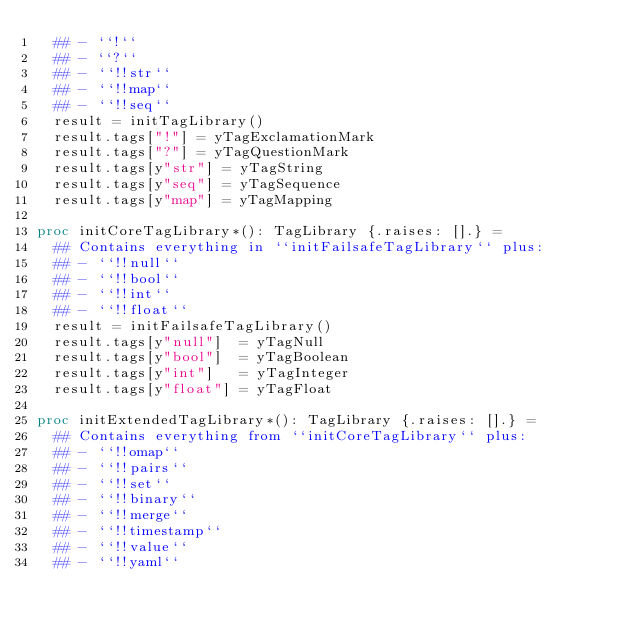Convert code to text. <code><loc_0><loc_0><loc_500><loc_500><_Nim_>  ## - ``!``
  ## - ``?``
  ## - ``!!str``
  ## - ``!!map``
  ## - ``!!seq``
  result = initTagLibrary()
  result.tags["!"] = yTagExclamationMark
  result.tags["?"] = yTagQuestionMark
  result.tags[y"str"] = yTagString
  result.tags[y"seq"] = yTagSequence
  result.tags[y"map"] = yTagMapping

proc initCoreTagLibrary*(): TagLibrary {.raises: [].} =
  ## Contains everything in ``initFailsafeTagLibrary`` plus:
  ## - ``!!null``
  ## - ``!!bool``
  ## - ``!!int``
  ## - ``!!float``
  result = initFailsafeTagLibrary()
  result.tags[y"null"]  = yTagNull
  result.tags[y"bool"]  = yTagBoolean
  result.tags[y"int"]   = yTagInteger
  result.tags[y"float"] = yTagFloat

proc initExtendedTagLibrary*(): TagLibrary {.raises: [].} =
  ## Contains everything from ``initCoreTagLibrary`` plus:
  ## - ``!!omap``
  ## - ``!!pairs``
  ## - ``!!set``
  ## - ``!!binary``
  ## - ``!!merge``
  ## - ``!!timestamp``
  ## - ``!!value``
  ## - ``!!yaml``</code> 